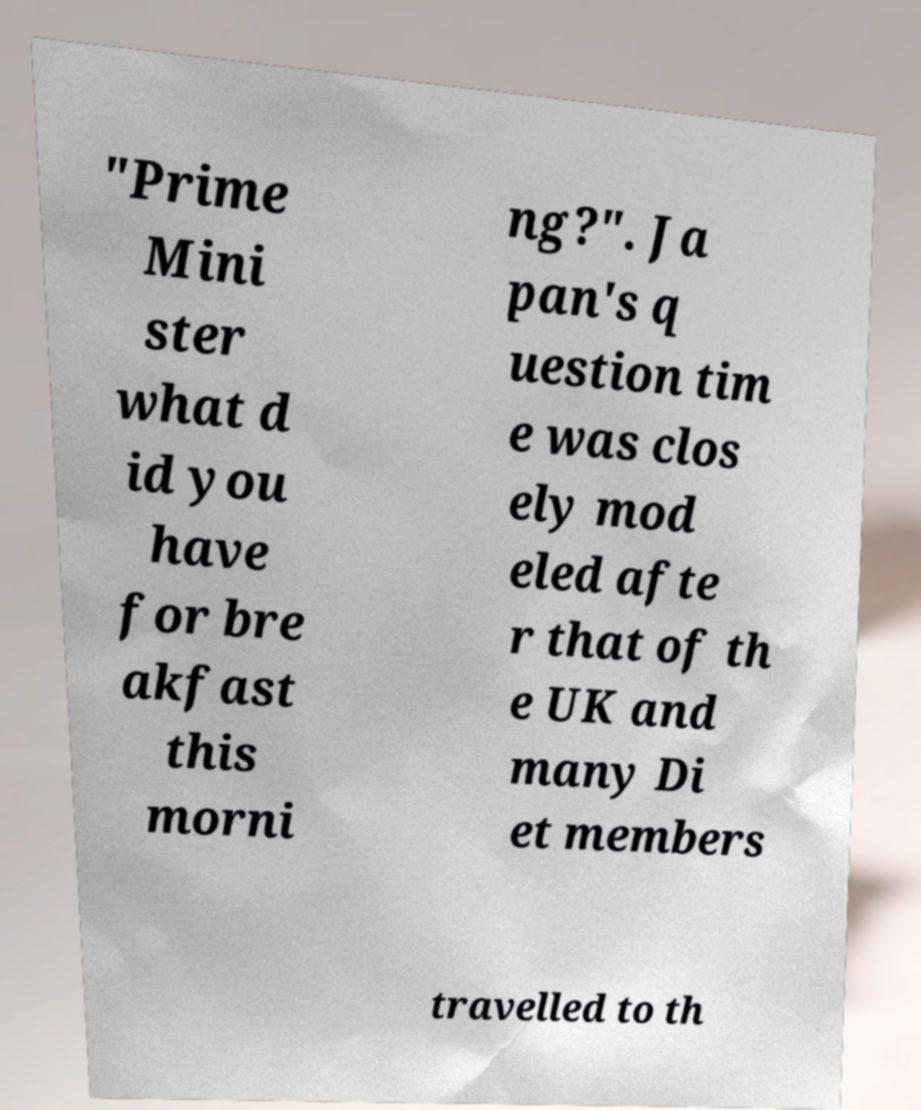What messages or text are displayed in this image? I need them in a readable, typed format. "Prime Mini ster what d id you have for bre akfast this morni ng?". Ja pan's q uestion tim e was clos ely mod eled afte r that of th e UK and many Di et members travelled to th 